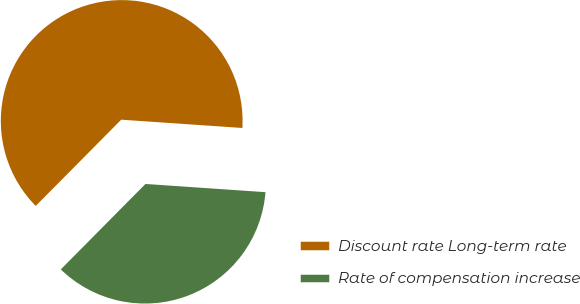Convert chart to OTSL. <chart><loc_0><loc_0><loc_500><loc_500><pie_chart><fcel>Discount rate Long-term rate<fcel>Rate of compensation increase<nl><fcel>63.66%<fcel>36.34%<nl></chart> 